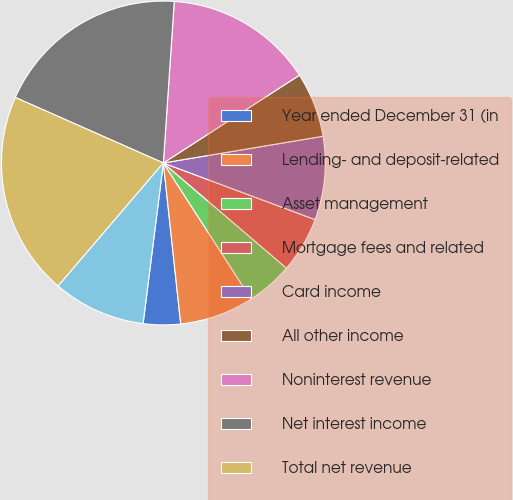Convert chart. <chart><loc_0><loc_0><loc_500><loc_500><pie_chart><fcel>Year ended December 31 (in<fcel>Lending- and deposit-related<fcel>Asset management<fcel>Mortgage fees and related<fcel>Card income<fcel>All other income<fcel>Noninterest revenue<fcel>Net interest income<fcel>Total net revenue<fcel>Provision for credit losses<nl><fcel>3.71%<fcel>7.41%<fcel>4.63%<fcel>5.56%<fcel>8.33%<fcel>6.48%<fcel>14.81%<fcel>19.44%<fcel>20.37%<fcel>9.26%<nl></chart> 